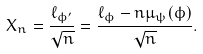Convert formula to latex. <formula><loc_0><loc_0><loc_500><loc_500>X _ { n } = \frac { \ell _ { \phi ^ { \prime } } } { \sqrt { n } } = \frac { \ell _ { \phi } - n \mu _ { \psi } ( \phi ) } { \sqrt { n } } .</formula> 